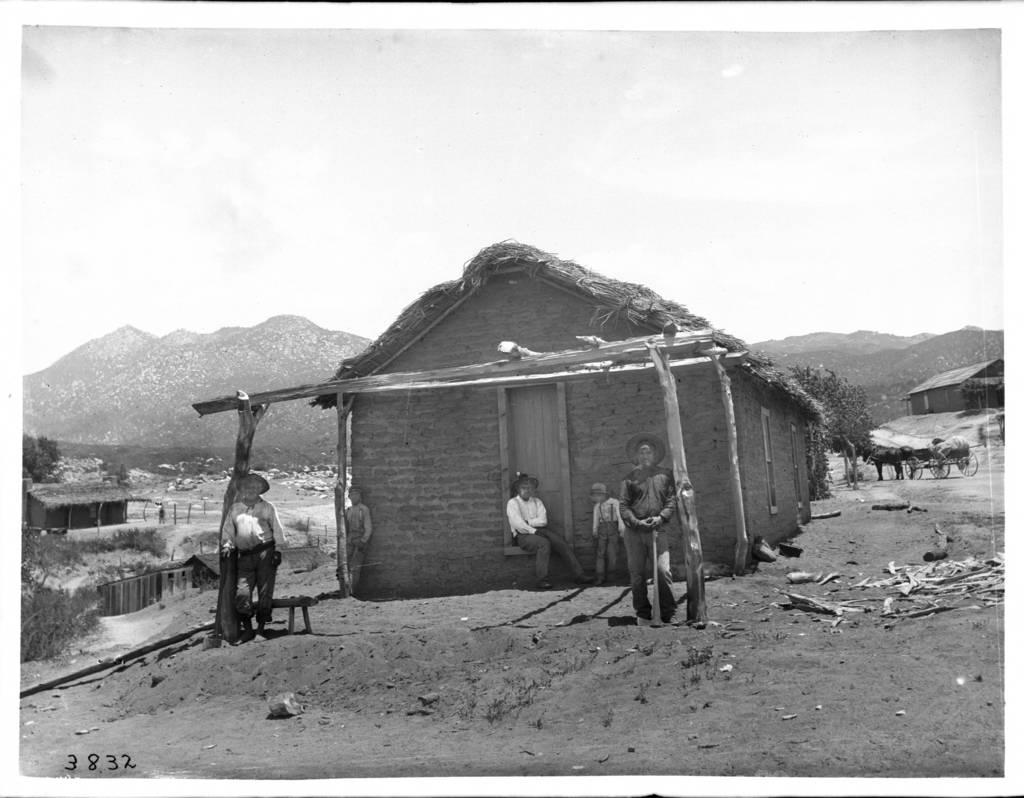What is the color scheme of the image? The image is black and white. Who or what can be seen in the image? There are people and houses in the image. What other natural elements are present in the image? There are trees, hills, and plants in the image. What type of vehicle is in the image? There is a cart in the image. What else can be seen on the ground in the image? The ground is visible with some objects visible. What part of the environment is visible in the image? The sky is visible in the image. Can you tell me how many bubbles are floating in the sky in the image? There are no bubbles present in the image; it is a black and white image with people, houses, trees, hills, plants, a cart, and visible ground and sky. 